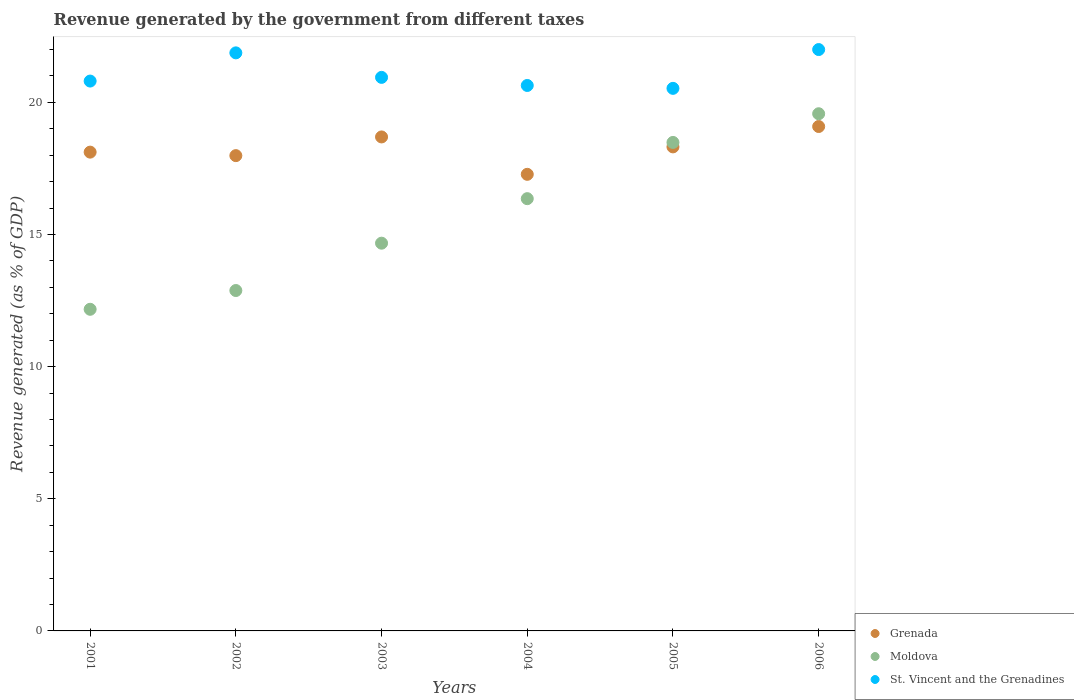Is the number of dotlines equal to the number of legend labels?
Your answer should be compact. Yes. What is the revenue generated by the government in Moldova in 2003?
Provide a short and direct response. 14.67. Across all years, what is the maximum revenue generated by the government in Grenada?
Your response must be concise. 19.09. Across all years, what is the minimum revenue generated by the government in St. Vincent and the Grenadines?
Keep it short and to the point. 20.53. In which year was the revenue generated by the government in Grenada maximum?
Keep it short and to the point. 2006. In which year was the revenue generated by the government in Moldova minimum?
Make the answer very short. 2001. What is the total revenue generated by the government in Moldova in the graph?
Offer a very short reply. 94.14. What is the difference between the revenue generated by the government in Grenada in 2001 and that in 2002?
Offer a very short reply. 0.13. What is the difference between the revenue generated by the government in St. Vincent and the Grenadines in 2002 and the revenue generated by the government in Moldova in 2005?
Your response must be concise. 3.39. What is the average revenue generated by the government in Grenada per year?
Ensure brevity in your answer.  18.25. In the year 2003, what is the difference between the revenue generated by the government in Moldova and revenue generated by the government in Grenada?
Your response must be concise. -4.02. In how many years, is the revenue generated by the government in Moldova greater than 13 %?
Ensure brevity in your answer.  4. What is the ratio of the revenue generated by the government in Moldova in 2003 to that in 2004?
Ensure brevity in your answer.  0.9. What is the difference between the highest and the second highest revenue generated by the government in St. Vincent and the Grenadines?
Give a very brief answer. 0.12. What is the difference between the highest and the lowest revenue generated by the government in Grenada?
Your answer should be very brief. 1.81. Is the sum of the revenue generated by the government in Grenada in 2002 and 2005 greater than the maximum revenue generated by the government in Moldova across all years?
Your answer should be very brief. Yes. Does the revenue generated by the government in St. Vincent and the Grenadines monotonically increase over the years?
Provide a short and direct response. No. Is the revenue generated by the government in Grenada strictly greater than the revenue generated by the government in St. Vincent and the Grenadines over the years?
Your answer should be very brief. No. How many dotlines are there?
Ensure brevity in your answer.  3. How many years are there in the graph?
Give a very brief answer. 6. What is the difference between two consecutive major ticks on the Y-axis?
Offer a very short reply. 5. Are the values on the major ticks of Y-axis written in scientific E-notation?
Provide a succinct answer. No. Does the graph contain any zero values?
Make the answer very short. No. Where does the legend appear in the graph?
Your answer should be very brief. Bottom right. How many legend labels are there?
Offer a terse response. 3. How are the legend labels stacked?
Your answer should be compact. Vertical. What is the title of the graph?
Offer a terse response. Revenue generated by the government from different taxes. Does "Cayman Islands" appear as one of the legend labels in the graph?
Your answer should be compact. No. What is the label or title of the Y-axis?
Your answer should be very brief. Revenue generated (as % of GDP). What is the Revenue generated (as % of GDP) of Grenada in 2001?
Offer a terse response. 18.12. What is the Revenue generated (as % of GDP) in Moldova in 2001?
Keep it short and to the point. 12.17. What is the Revenue generated (as % of GDP) of St. Vincent and the Grenadines in 2001?
Provide a succinct answer. 20.81. What is the Revenue generated (as % of GDP) in Grenada in 2002?
Your response must be concise. 17.99. What is the Revenue generated (as % of GDP) of Moldova in 2002?
Your response must be concise. 12.88. What is the Revenue generated (as % of GDP) in St. Vincent and the Grenadines in 2002?
Keep it short and to the point. 21.88. What is the Revenue generated (as % of GDP) of Grenada in 2003?
Give a very brief answer. 18.69. What is the Revenue generated (as % of GDP) in Moldova in 2003?
Keep it short and to the point. 14.67. What is the Revenue generated (as % of GDP) of St. Vincent and the Grenadines in 2003?
Your answer should be very brief. 20.95. What is the Revenue generated (as % of GDP) in Grenada in 2004?
Your response must be concise. 17.28. What is the Revenue generated (as % of GDP) in Moldova in 2004?
Your answer should be compact. 16.36. What is the Revenue generated (as % of GDP) in St. Vincent and the Grenadines in 2004?
Ensure brevity in your answer.  20.64. What is the Revenue generated (as % of GDP) of Grenada in 2005?
Make the answer very short. 18.32. What is the Revenue generated (as % of GDP) of Moldova in 2005?
Offer a terse response. 18.49. What is the Revenue generated (as % of GDP) in St. Vincent and the Grenadines in 2005?
Your answer should be very brief. 20.53. What is the Revenue generated (as % of GDP) in Grenada in 2006?
Make the answer very short. 19.09. What is the Revenue generated (as % of GDP) in Moldova in 2006?
Give a very brief answer. 19.57. What is the Revenue generated (as % of GDP) of St. Vincent and the Grenadines in 2006?
Your answer should be very brief. 22. Across all years, what is the maximum Revenue generated (as % of GDP) in Grenada?
Your answer should be very brief. 19.09. Across all years, what is the maximum Revenue generated (as % of GDP) of Moldova?
Offer a terse response. 19.57. Across all years, what is the maximum Revenue generated (as % of GDP) of St. Vincent and the Grenadines?
Your answer should be compact. 22. Across all years, what is the minimum Revenue generated (as % of GDP) in Grenada?
Your response must be concise. 17.28. Across all years, what is the minimum Revenue generated (as % of GDP) of Moldova?
Give a very brief answer. 12.17. Across all years, what is the minimum Revenue generated (as % of GDP) of St. Vincent and the Grenadines?
Offer a terse response. 20.53. What is the total Revenue generated (as % of GDP) in Grenada in the graph?
Offer a terse response. 109.48. What is the total Revenue generated (as % of GDP) of Moldova in the graph?
Make the answer very short. 94.14. What is the total Revenue generated (as % of GDP) of St. Vincent and the Grenadines in the graph?
Offer a terse response. 126.8. What is the difference between the Revenue generated (as % of GDP) in Grenada in 2001 and that in 2002?
Provide a short and direct response. 0.13. What is the difference between the Revenue generated (as % of GDP) in Moldova in 2001 and that in 2002?
Provide a short and direct response. -0.71. What is the difference between the Revenue generated (as % of GDP) of St. Vincent and the Grenadines in 2001 and that in 2002?
Make the answer very short. -1.07. What is the difference between the Revenue generated (as % of GDP) in Grenada in 2001 and that in 2003?
Give a very brief answer. -0.57. What is the difference between the Revenue generated (as % of GDP) of Moldova in 2001 and that in 2003?
Your response must be concise. -2.5. What is the difference between the Revenue generated (as % of GDP) of St. Vincent and the Grenadines in 2001 and that in 2003?
Provide a short and direct response. -0.14. What is the difference between the Revenue generated (as % of GDP) of Grenada in 2001 and that in 2004?
Offer a very short reply. 0.84. What is the difference between the Revenue generated (as % of GDP) in Moldova in 2001 and that in 2004?
Your answer should be compact. -4.19. What is the difference between the Revenue generated (as % of GDP) in St. Vincent and the Grenadines in 2001 and that in 2004?
Your response must be concise. 0.17. What is the difference between the Revenue generated (as % of GDP) in Grenada in 2001 and that in 2005?
Give a very brief answer. -0.2. What is the difference between the Revenue generated (as % of GDP) of Moldova in 2001 and that in 2005?
Give a very brief answer. -6.31. What is the difference between the Revenue generated (as % of GDP) of St. Vincent and the Grenadines in 2001 and that in 2005?
Provide a succinct answer. 0.28. What is the difference between the Revenue generated (as % of GDP) in Grenada in 2001 and that in 2006?
Ensure brevity in your answer.  -0.97. What is the difference between the Revenue generated (as % of GDP) in Moldova in 2001 and that in 2006?
Give a very brief answer. -7.4. What is the difference between the Revenue generated (as % of GDP) in St. Vincent and the Grenadines in 2001 and that in 2006?
Provide a short and direct response. -1.19. What is the difference between the Revenue generated (as % of GDP) in Grenada in 2002 and that in 2003?
Your response must be concise. -0.71. What is the difference between the Revenue generated (as % of GDP) in Moldova in 2002 and that in 2003?
Give a very brief answer. -1.79. What is the difference between the Revenue generated (as % of GDP) of St. Vincent and the Grenadines in 2002 and that in 2003?
Ensure brevity in your answer.  0.93. What is the difference between the Revenue generated (as % of GDP) in Grenada in 2002 and that in 2004?
Give a very brief answer. 0.71. What is the difference between the Revenue generated (as % of GDP) in Moldova in 2002 and that in 2004?
Make the answer very short. -3.48. What is the difference between the Revenue generated (as % of GDP) of St. Vincent and the Grenadines in 2002 and that in 2004?
Ensure brevity in your answer.  1.23. What is the difference between the Revenue generated (as % of GDP) in Grenada in 2002 and that in 2005?
Offer a terse response. -0.33. What is the difference between the Revenue generated (as % of GDP) in Moldova in 2002 and that in 2005?
Offer a very short reply. -5.6. What is the difference between the Revenue generated (as % of GDP) of St. Vincent and the Grenadines in 2002 and that in 2005?
Keep it short and to the point. 1.34. What is the difference between the Revenue generated (as % of GDP) in Grenada in 2002 and that in 2006?
Provide a short and direct response. -1.1. What is the difference between the Revenue generated (as % of GDP) in Moldova in 2002 and that in 2006?
Your response must be concise. -6.69. What is the difference between the Revenue generated (as % of GDP) of St. Vincent and the Grenadines in 2002 and that in 2006?
Provide a short and direct response. -0.12. What is the difference between the Revenue generated (as % of GDP) of Grenada in 2003 and that in 2004?
Your answer should be compact. 1.41. What is the difference between the Revenue generated (as % of GDP) in Moldova in 2003 and that in 2004?
Provide a short and direct response. -1.68. What is the difference between the Revenue generated (as % of GDP) in St. Vincent and the Grenadines in 2003 and that in 2004?
Provide a short and direct response. 0.31. What is the difference between the Revenue generated (as % of GDP) of Grenada in 2003 and that in 2005?
Offer a terse response. 0.38. What is the difference between the Revenue generated (as % of GDP) in Moldova in 2003 and that in 2005?
Make the answer very short. -3.81. What is the difference between the Revenue generated (as % of GDP) of St. Vincent and the Grenadines in 2003 and that in 2005?
Provide a succinct answer. 0.42. What is the difference between the Revenue generated (as % of GDP) of Grenada in 2003 and that in 2006?
Your answer should be compact. -0.39. What is the difference between the Revenue generated (as % of GDP) in Moldova in 2003 and that in 2006?
Your answer should be very brief. -4.9. What is the difference between the Revenue generated (as % of GDP) of St. Vincent and the Grenadines in 2003 and that in 2006?
Your answer should be compact. -1.05. What is the difference between the Revenue generated (as % of GDP) of Grenada in 2004 and that in 2005?
Provide a short and direct response. -1.04. What is the difference between the Revenue generated (as % of GDP) of Moldova in 2004 and that in 2005?
Offer a terse response. -2.13. What is the difference between the Revenue generated (as % of GDP) of St. Vincent and the Grenadines in 2004 and that in 2005?
Your answer should be very brief. 0.11. What is the difference between the Revenue generated (as % of GDP) of Grenada in 2004 and that in 2006?
Keep it short and to the point. -1.81. What is the difference between the Revenue generated (as % of GDP) in Moldova in 2004 and that in 2006?
Your answer should be very brief. -3.21. What is the difference between the Revenue generated (as % of GDP) of St. Vincent and the Grenadines in 2004 and that in 2006?
Provide a succinct answer. -1.36. What is the difference between the Revenue generated (as % of GDP) in Grenada in 2005 and that in 2006?
Offer a very short reply. -0.77. What is the difference between the Revenue generated (as % of GDP) in Moldova in 2005 and that in 2006?
Ensure brevity in your answer.  -1.09. What is the difference between the Revenue generated (as % of GDP) in St. Vincent and the Grenadines in 2005 and that in 2006?
Offer a very short reply. -1.47. What is the difference between the Revenue generated (as % of GDP) of Grenada in 2001 and the Revenue generated (as % of GDP) of Moldova in 2002?
Give a very brief answer. 5.24. What is the difference between the Revenue generated (as % of GDP) of Grenada in 2001 and the Revenue generated (as % of GDP) of St. Vincent and the Grenadines in 2002?
Give a very brief answer. -3.76. What is the difference between the Revenue generated (as % of GDP) in Moldova in 2001 and the Revenue generated (as % of GDP) in St. Vincent and the Grenadines in 2002?
Keep it short and to the point. -9.7. What is the difference between the Revenue generated (as % of GDP) of Grenada in 2001 and the Revenue generated (as % of GDP) of Moldova in 2003?
Your answer should be compact. 3.45. What is the difference between the Revenue generated (as % of GDP) of Grenada in 2001 and the Revenue generated (as % of GDP) of St. Vincent and the Grenadines in 2003?
Your answer should be very brief. -2.83. What is the difference between the Revenue generated (as % of GDP) of Moldova in 2001 and the Revenue generated (as % of GDP) of St. Vincent and the Grenadines in 2003?
Keep it short and to the point. -8.78. What is the difference between the Revenue generated (as % of GDP) in Grenada in 2001 and the Revenue generated (as % of GDP) in Moldova in 2004?
Offer a terse response. 1.76. What is the difference between the Revenue generated (as % of GDP) in Grenada in 2001 and the Revenue generated (as % of GDP) in St. Vincent and the Grenadines in 2004?
Keep it short and to the point. -2.52. What is the difference between the Revenue generated (as % of GDP) in Moldova in 2001 and the Revenue generated (as % of GDP) in St. Vincent and the Grenadines in 2004?
Your answer should be very brief. -8.47. What is the difference between the Revenue generated (as % of GDP) of Grenada in 2001 and the Revenue generated (as % of GDP) of Moldova in 2005?
Make the answer very short. -0.37. What is the difference between the Revenue generated (as % of GDP) in Grenada in 2001 and the Revenue generated (as % of GDP) in St. Vincent and the Grenadines in 2005?
Provide a succinct answer. -2.41. What is the difference between the Revenue generated (as % of GDP) in Moldova in 2001 and the Revenue generated (as % of GDP) in St. Vincent and the Grenadines in 2005?
Make the answer very short. -8.36. What is the difference between the Revenue generated (as % of GDP) in Grenada in 2001 and the Revenue generated (as % of GDP) in Moldova in 2006?
Your answer should be compact. -1.45. What is the difference between the Revenue generated (as % of GDP) of Grenada in 2001 and the Revenue generated (as % of GDP) of St. Vincent and the Grenadines in 2006?
Keep it short and to the point. -3.88. What is the difference between the Revenue generated (as % of GDP) of Moldova in 2001 and the Revenue generated (as % of GDP) of St. Vincent and the Grenadines in 2006?
Your response must be concise. -9.83. What is the difference between the Revenue generated (as % of GDP) of Grenada in 2002 and the Revenue generated (as % of GDP) of Moldova in 2003?
Your answer should be very brief. 3.31. What is the difference between the Revenue generated (as % of GDP) of Grenada in 2002 and the Revenue generated (as % of GDP) of St. Vincent and the Grenadines in 2003?
Keep it short and to the point. -2.96. What is the difference between the Revenue generated (as % of GDP) of Moldova in 2002 and the Revenue generated (as % of GDP) of St. Vincent and the Grenadines in 2003?
Your answer should be compact. -8.07. What is the difference between the Revenue generated (as % of GDP) in Grenada in 2002 and the Revenue generated (as % of GDP) in Moldova in 2004?
Ensure brevity in your answer.  1.63. What is the difference between the Revenue generated (as % of GDP) in Grenada in 2002 and the Revenue generated (as % of GDP) in St. Vincent and the Grenadines in 2004?
Provide a short and direct response. -2.65. What is the difference between the Revenue generated (as % of GDP) of Moldova in 2002 and the Revenue generated (as % of GDP) of St. Vincent and the Grenadines in 2004?
Make the answer very short. -7.76. What is the difference between the Revenue generated (as % of GDP) in Grenada in 2002 and the Revenue generated (as % of GDP) in Moldova in 2005?
Your answer should be compact. -0.5. What is the difference between the Revenue generated (as % of GDP) of Grenada in 2002 and the Revenue generated (as % of GDP) of St. Vincent and the Grenadines in 2005?
Your response must be concise. -2.55. What is the difference between the Revenue generated (as % of GDP) in Moldova in 2002 and the Revenue generated (as % of GDP) in St. Vincent and the Grenadines in 2005?
Your answer should be very brief. -7.65. What is the difference between the Revenue generated (as % of GDP) in Grenada in 2002 and the Revenue generated (as % of GDP) in Moldova in 2006?
Your answer should be very brief. -1.58. What is the difference between the Revenue generated (as % of GDP) of Grenada in 2002 and the Revenue generated (as % of GDP) of St. Vincent and the Grenadines in 2006?
Provide a succinct answer. -4.01. What is the difference between the Revenue generated (as % of GDP) in Moldova in 2002 and the Revenue generated (as % of GDP) in St. Vincent and the Grenadines in 2006?
Offer a terse response. -9.12. What is the difference between the Revenue generated (as % of GDP) in Grenada in 2003 and the Revenue generated (as % of GDP) in Moldova in 2004?
Provide a short and direct response. 2.34. What is the difference between the Revenue generated (as % of GDP) in Grenada in 2003 and the Revenue generated (as % of GDP) in St. Vincent and the Grenadines in 2004?
Offer a very short reply. -1.95. What is the difference between the Revenue generated (as % of GDP) of Moldova in 2003 and the Revenue generated (as % of GDP) of St. Vincent and the Grenadines in 2004?
Offer a very short reply. -5.97. What is the difference between the Revenue generated (as % of GDP) in Grenada in 2003 and the Revenue generated (as % of GDP) in Moldova in 2005?
Your response must be concise. 0.21. What is the difference between the Revenue generated (as % of GDP) in Grenada in 2003 and the Revenue generated (as % of GDP) in St. Vincent and the Grenadines in 2005?
Offer a terse response. -1.84. What is the difference between the Revenue generated (as % of GDP) in Moldova in 2003 and the Revenue generated (as % of GDP) in St. Vincent and the Grenadines in 2005?
Give a very brief answer. -5.86. What is the difference between the Revenue generated (as % of GDP) of Grenada in 2003 and the Revenue generated (as % of GDP) of Moldova in 2006?
Provide a short and direct response. -0.88. What is the difference between the Revenue generated (as % of GDP) of Grenada in 2003 and the Revenue generated (as % of GDP) of St. Vincent and the Grenadines in 2006?
Give a very brief answer. -3.31. What is the difference between the Revenue generated (as % of GDP) in Moldova in 2003 and the Revenue generated (as % of GDP) in St. Vincent and the Grenadines in 2006?
Offer a very short reply. -7.33. What is the difference between the Revenue generated (as % of GDP) of Grenada in 2004 and the Revenue generated (as % of GDP) of Moldova in 2005?
Your response must be concise. -1.21. What is the difference between the Revenue generated (as % of GDP) of Grenada in 2004 and the Revenue generated (as % of GDP) of St. Vincent and the Grenadines in 2005?
Ensure brevity in your answer.  -3.25. What is the difference between the Revenue generated (as % of GDP) of Moldova in 2004 and the Revenue generated (as % of GDP) of St. Vincent and the Grenadines in 2005?
Make the answer very short. -4.17. What is the difference between the Revenue generated (as % of GDP) in Grenada in 2004 and the Revenue generated (as % of GDP) in Moldova in 2006?
Your answer should be compact. -2.29. What is the difference between the Revenue generated (as % of GDP) in Grenada in 2004 and the Revenue generated (as % of GDP) in St. Vincent and the Grenadines in 2006?
Give a very brief answer. -4.72. What is the difference between the Revenue generated (as % of GDP) in Moldova in 2004 and the Revenue generated (as % of GDP) in St. Vincent and the Grenadines in 2006?
Offer a terse response. -5.64. What is the difference between the Revenue generated (as % of GDP) of Grenada in 2005 and the Revenue generated (as % of GDP) of Moldova in 2006?
Offer a very short reply. -1.25. What is the difference between the Revenue generated (as % of GDP) in Grenada in 2005 and the Revenue generated (as % of GDP) in St. Vincent and the Grenadines in 2006?
Your response must be concise. -3.68. What is the difference between the Revenue generated (as % of GDP) of Moldova in 2005 and the Revenue generated (as % of GDP) of St. Vincent and the Grenadines in 2006?
Make the answer very short. -3.51. What is the average Revenue generated (as % of GDP) of Grenada per year?
Provide a succinct answer. 18.25. What is the average Revenue generated (as % of GDP) of Moldova per year?
Provide a short and direct response. 15.69. What is the average Revenue generated (as % of GDP) in St. Vincent and the Grenadines per year?
Keep it short and to the point. 21.13. In the year 2001, what is the difference between the Revenue generated (as % of GDP) in Grenada and Revenue generated (as % of GDP) in Moldova?
Your response must be concise. 5.95. In the year 2001, what is the difference between the Revenue generated (as % of GDP) in Grenada and Revenue generated (as % of GDP) in St. Vincent and the Grenadines?
Make the answer very short. -2.69. In the year 2001, what is the difference between the Revenue generated (as % of GDP) of Moldova and Revenue generated (as % of GDP) of St. Vincent and the Grenadines?
Make the answer very short. -8.64. In the year 2002, what is the difference between the Revenue generated (as % of GDP) in Grenada and Revenue generated (as % of GDP) in Moldova?
Ensure brevity in your answer.  5.1. In the year 2002, what is the difference between the Revenue generated (as % of GDP) in Grenada and Revenue generated (as % of GDP) in St. Vincent and the Grenadines?
Give a very brief answer. -3.89. In the year 2002, what is the difference between the Revenue generated (as % of GDP) in Moldova and Revenue generated (as % of GDP) in St. Vincent and the Grenadines?
Provide a succinct answer. -8.99. In the year 2003, what is the difference between the Revenue generated (as % of GDP) of Grenada and Revenue generated (as % of GDP) of Moldova?
Give a very brief answer. 4.02. In the year 2003, what is the difference between the Revenue generated (as % of GDP) of Grenada and Revenue generated (as % of GDP) of St. Vincent and the Grenadines?
Offer a terse response. -2.25. In the year 2003, what is the difference between the Revenue generated (as % of GDP) in Moldova and Revenue generated (as % of GDP) in St. Vincent and the Grenadines?
Ensure brevity in your answer.  -6.27. In the year 2004, what is the difference between the Revenue generated (as % of GDP) in Grenada and Revenue generated (as % of GDP) in Moldova?
Your answer should be very brief. 0.92. In the year 2004, what is the difference between the Revenue generated (as % of GDP) of Grenada and Revenue generated (as % of GDP) of St. Vincent and the Grenadines?
Your response must be concise. -3.36. In the year 2004, what is the difference between the Revenue generated (as % of GDP) of Moldova and Revenue generated (as % of GDP) of St. Vincent and the Grenadines?
Your answer should be compact. -4.28. In the year 2005, what is the difference between the Revenue generated (as % of GDP) in Grenada and Revenue generated (as % of GDP) in Moldova?
Offer a very short reply. -0.17. In the year 2005, what is the difference between the Revenue generated (as % of GDP) of Grenada and Revenue generated (as % of GDP) of St. Vincent and the Grenadines?
Your response must be concise. -2.21. In the year 2005, what is the difference between the Revenue generated (as % of GDP) in Moldova and Revenue generated (as % of GDP) in St. Vincent and the Grenadines?
Your answer should be compact. -2.05. In the year 2006, what is the difference between the Revenue generated (as % of GDP) in Grenada and Revenue generated (as % of GDP) in Moldova?
Give a very brief answer. -0.48. In the year 2006, what is the difference between the Revenue generated (as % of GDP) of Grenada and Revenue generated (as % of GDP) of St. Vincent and the Grenadines?
Your answer should be very brief. -2.91. In the year 2006, what is the difference between the Revenue generated (as % of GDP) in Moldova and Revenue generated (as % of GDP) in St. Vincent and the Grenadines?
Keep it short and to the point. -2.43. What is the ratio of the Revenue generated (as % of GDP) of Grenada in 2001 to that in 2002?
Your answer should be compact. 1.01. What is the ratio of the Revenue generated (as % of GDP) of Moldova in 2001 to that in 2002?
Ensure brevity in your answer.  0.94. What is the ratio of the Revenue generated (as % of GDP) of St. Vincent and the Grenadines in 2001 to that in 2002?
Your response must be concise. 0.95. What is the ratio of the Revenue generated (as % of GDP) in Grenada in 2001 to that in 2003?
Your answer should be very brief. 0.97. What is the ratio of the Revenue generated (as % of GDP) of Moldova in 2001 to that in 2003?
Your answer should be very brief. 0.83. What is the ratio of the Revenue generated (as % of GDP) of St. Vincent and the Grenadines in 2001 to that in 2003?
Keep it short and to the point. 0.99. What is the ratio of the Revenue generated (as % of GDP) in Grenada in 2001 to that in 2004?
Offer a very short reply. 1.05. What is the ratio of the Revenue generated (as % of GDP) of Moldova in 2001 to that in 2004?
Keep it short and to the point. 0.74. What is the ratio of the Revenue generated (as % of GDP) in St. Vincent and the Grenadines in 2001 to that in 2004?
Offer a very short reply. 1.01. What is the ratio of the Revenue generated (as % of GDP) in Grenada in 2001 to that in 2005?
Provide a succinct answer. 0.99. What is the ratio of the Revenue generated (as % of GDP) in Moldova in 2001 to that in 2005?
Provide a short and direct response. 0.66. What is the ratio of the Revenue generated (as % of GDP) of St. Vincent and the Grenadines in 2001 to that in 2005?
Provide a short and direct response. 1.01. What is the ratio of the Revenue generated (as % of GDP) of Grenada in 2001 to that in 2006?
Keep it short and to the point. 0.95. What is the ratio of the Revenue generated (as % of GDP) of Moldova in 2001 to that in 2006?
Make the answer very short. 0.62. What is the ratio of the Revenue generated (as % of GDP) in St. Vincent and the Grenadines in 2001 to that in 2006?
Provide a succinct answer. 0.95. What is the ratio of the Revenue generated (as % of GDP) in Grenada in 2002 to that in 2003?
Your answer should be compact. 0.96. What is the ratio of the Revenue generated (as % of GDP) of Moldova in 2002 to that in 2003?
Offer a very short reply. 0.88. What is the ratio of the Revenue generated (as % of GDP) in St. Vincent and the Grenadines in 2002 to that in 2003?
Provide a short and direct response. 1.04. What is the ratio of the Revenue generated (as % of GDP) in Grenada in 2002 to that in 2004?
Offer a terse response. 1.04. What is the ratio of the Revenue generated (as % of GDP) in Moldova in 2002 to that in 2004?
Provide a short and direct response. 0.79. What is the ratio of the Revenue generated (as % of GDP) in St. Vincent and the Grenadines in 2002 to that in 2004?
Offer a terse response. 1.06. What is the ratio of the Revenue generated (as % of GDP) in Grenada in 2002 to that in 2005?
Your answer should be very brief. 0.98. What is the ratio of the Revenue generated (as % of GDP) of Moldova in 2002 to that in 2005?
Ensure brevity in your answer.  0.7. What is the ratio of the Revenue generated (as % of GDP) of St. Vincent and the Grenadines in 2002 to that in 2005?
Provide a short and direct response. 1.07. What is the ratio of the Revenue generated (as % of GDP) in Grenada in 2002 to that in 2006?
Ensure brevity in your answer.  0.94. What is the ratio of the Revenue generated (as % of GDP) of Moldova in 2002 to that in 2006?
Provide a short and direct response. 0.66. What is the ratio of the Revenue generated (as % of GDP) in Grenada in 2003 to that in 2004?
Offer a very short reply. 1.08. What is the ratio of the Revenue generated (as % of GDP) in Moldova in 2003 to that in 2004?
Your answer should be compact. 0.9. What is the ratio of the Revenue generated (as % of GDP) in St. Vincent and the Grenadines in 2003 to that in 2004?
Offer a very short reply. 1.01. What is the ratio of the Revenue generated (as % of GDP) of Grenada in 2003 to that in 2005?
Keep it short and to the point. 1.02. What is the ratio of the Revenue generated (as % of GDP) in Moldova in 2003 to that in 2005?
Give a very brief answer. 0.79. What is the ratio of the Revenue generated (as % of GDP) of St. Vincent and the Grenadines in 2003 to that in 2005?
Ensure brevity in your answer.  1.02. What is the ratio of the Revenue generated (as % of GDP) of Grenada in 2003 to that in 2006?
Make the answer very short. 0.98. What is the ratio of the Revenue generated (as % of GDP) of Moldova in 2003 to that in 2006?
Keep it short and to the point. 0.75. What is the ratio of the Revenue generated (as % of GDP) of St. Vincent and the Grenadines in 2003 to that in 2006?
Make the answer very short. 0.95. What is the ratio of the Revenue generated (as % of GDP) in Grenada in 2004 to that in 2005?
Give a very brief answer. 0.94. What is the ratio of the Revenue generated (as % of GDP) in Moldova in 2004 to that in 2005?
Provide a short and direct response. 0.88. What is the ratio of the Revenue generated (as % of GDP) in St. Vincent and the Grenadines in 2004 to that in 2005?
Offer a very short reply. 1.01. What is the ratio of the Revenue generated (as % of GDP) in Grenada in 2004 to that in 2006?
Offer a terse response. 0.91. What is the ratio of the Revenue generated (as % of GDP) in Moldova in 2004 to that in 2006?
Make the answer very short. 0.84. What is the ratio of the Revenue generated (as % of GDP) in St. Vincent and the Grenadines in 2004 to that in 2006?
Offer a very short reply. 0.94. What is the ratio of the Revenue generated (as % of GDP) of Grenada in 2005 to that in 2006?
Your response must be concise. 0.96. What is the ratio of the Revenue generated (as % of GDP) of Moldova in 2005 to that in 2006?
Give a very brief answer. 0.94. What is the difference between the highest and the second highest Revenue generated (as % of GDP) in Grenada?
Offer a terse response. 0.39. What is the difference between the highest and the second highest Revenue generated (as % of GDP) in Moldova?
Ensure brevity in your answer.  1.09. What is the difference between the highest and the second highest Revenue generated (as % of GDP) of St. Vincent and the Grenadines?
Ensure brevity in your answer.  0.12. What is the difference between the highest and the lowest Revenue generated (as % of GDP) in Grenada?
Your answer should be very brief. 1.81. What is the difference between the highest and the lowest Revenue generated (as % of GDP) in Moldova?
Your answer should be compact. 7.4. What is the difference between the highest and the lowest Revenue generated (as % of GDP) in St. Vincent and the Grenadines?
Ensure brevity in your answer.  1.47. 